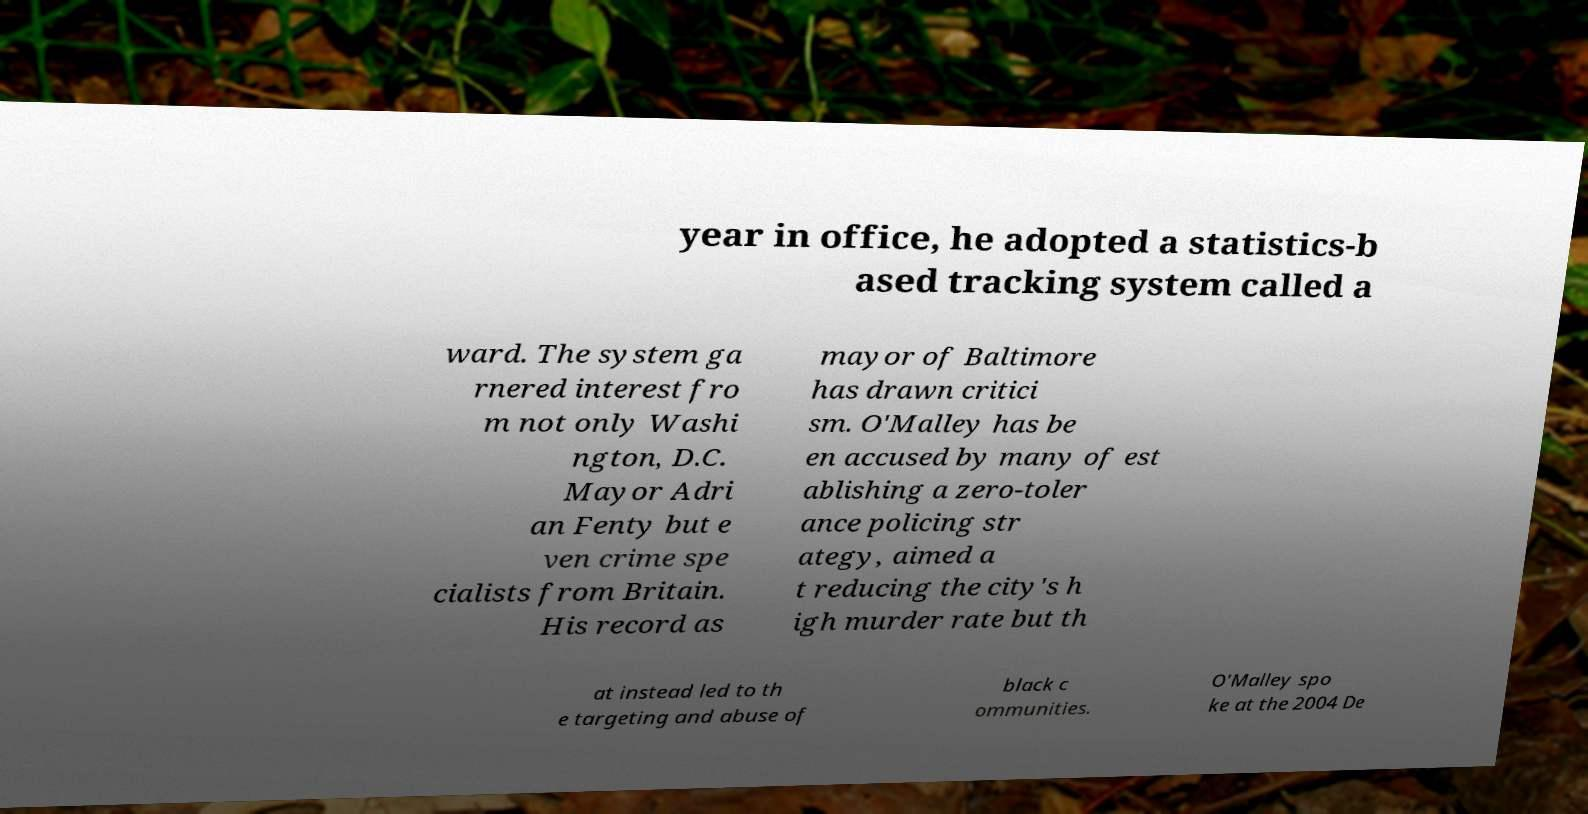I need the written content from this picture converted into text. Can you do that? year in office, he adopted a statistics-b ased tracking system called a ward. The system ga rnered interest fro m not only Washi ngton, D.C. Mayor Adri an Fenty but e ven crime spe cialists from Britain. His record as mayor of Baltimore has drawn critici sm. O'Malley has be en accused by many of est ablishing a zero-toler ance policing str ategy, aimed a t reducing the city's h igh murder rate but th at instead led to th e targeting and abuse of black c ommunities. O'Malley spo ke at the 2004 De 